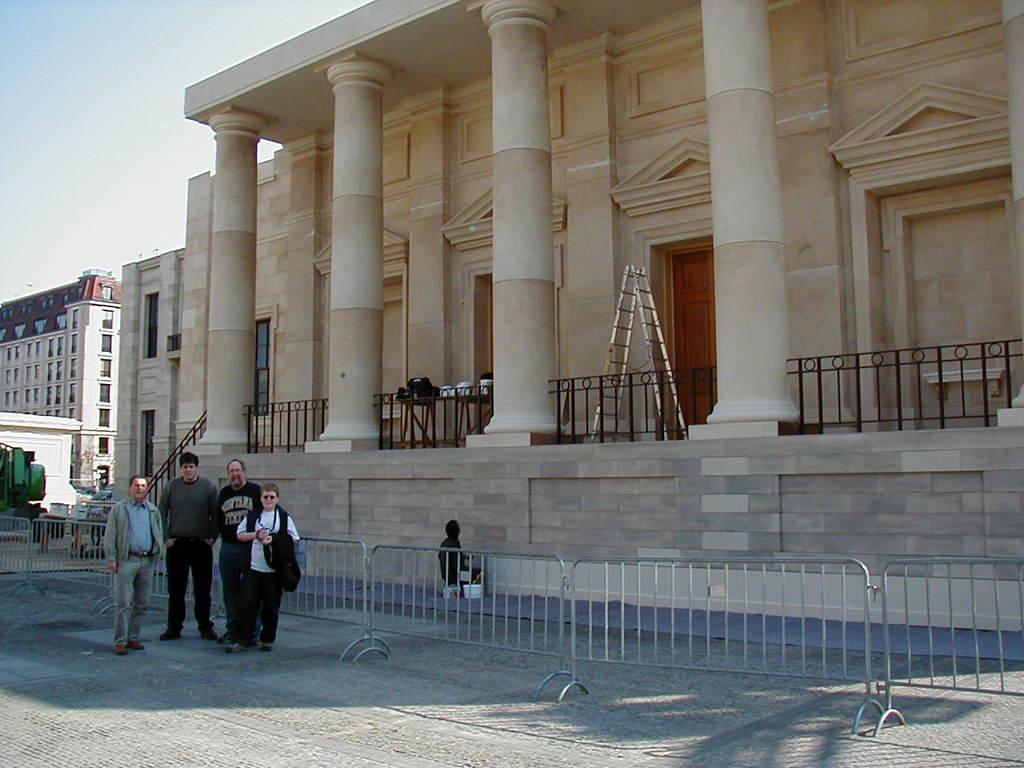Can you describe this image briefly? In this image, we can see buildings, railings, some stands and there are people on the road and one of them is holding a coat and we can see pillars and some other objects. At the top, there is sky. 